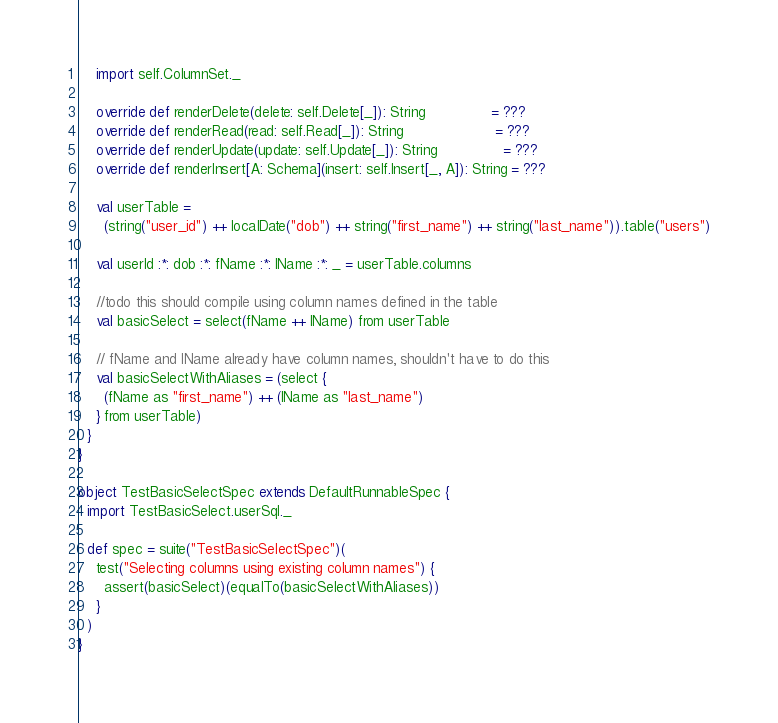<code> <loc_0><loc_0><loc_500><loc_500><_Scala_>    import self.ColumnSet._

    override def renderDelete(delete: self.Delete[_]): String               = ???
    override def renderRead(read: self.Read[_]): String                     = ???
    override def renderUpdate(update: self.Update[_]): String               = ???
    override def renderInsert[A: Schema](insert: self.Insert[_, A]): String = ???

    val userTable =
      (string("user_id") ++ localDate("dob") ++ string("first_name") ++ string("last_name")).table("users")

    val userId :*: dob :*: fName :*: lName :*: _ = userTable.columns

    //todo this should compile using column names defined in the table
    val basicSelect = select(fName ++ lName) from userTable

    // fName and lName already have column names, shouldn't have to do this
    val basicSelectWithAliases = (select {
      (fName as "first_name") ++ (lName as "last_name")
    } from userTable)
  }
}

object TestBasicSelectSpec extends DefaultRunnableSpec {
  import TestBasicSelect.userSql._

  def spec = suite("TestBasicSelectSpec")(
    test("Selecting columns using existing column names") {
      assert(basicSelect)(equalTo(basicSelectWithAliases))
    }
  )
}
</code> 